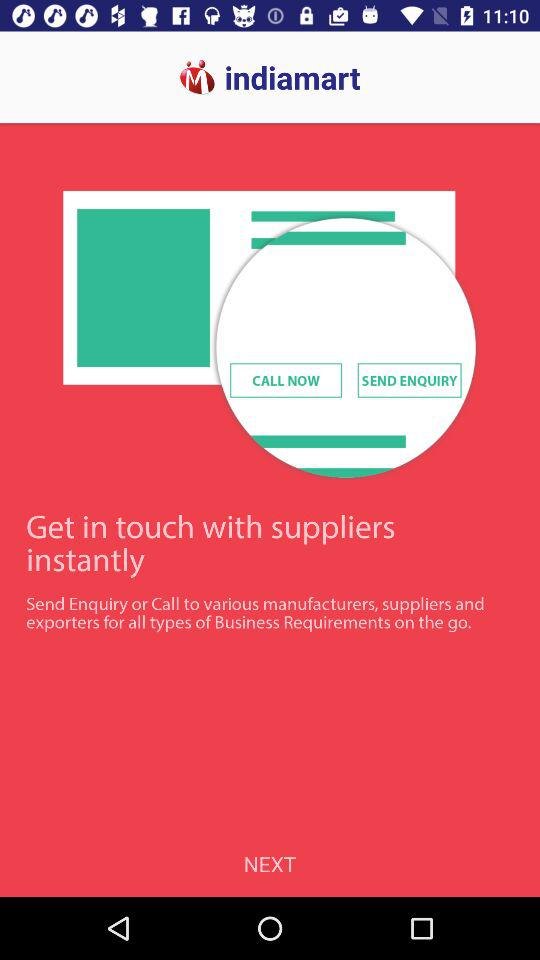What is the name of the application? The name of the application is "indiamart". 